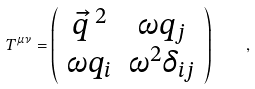<formula> <loc_0><loc_0><loc_500><loc_500>T ^ { \mu \nu } = \left ( \begin{array} { c c } { \vec { q } \, ^ { 2 } } & { \omega q _ { j } } \\ { \omega q _ { i } } & \omega ^ { 2 } \delta _ { i j } \\ \end{array} \right ) \quad ,</formula> 